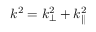Convert formula to latex. <formula><loc_0><loc_0><loc_500><loc_500>k ^ { 2 } = k _ { \perp } ^ { 2 } + k _ { \| } ^ { 2 }</formula> 